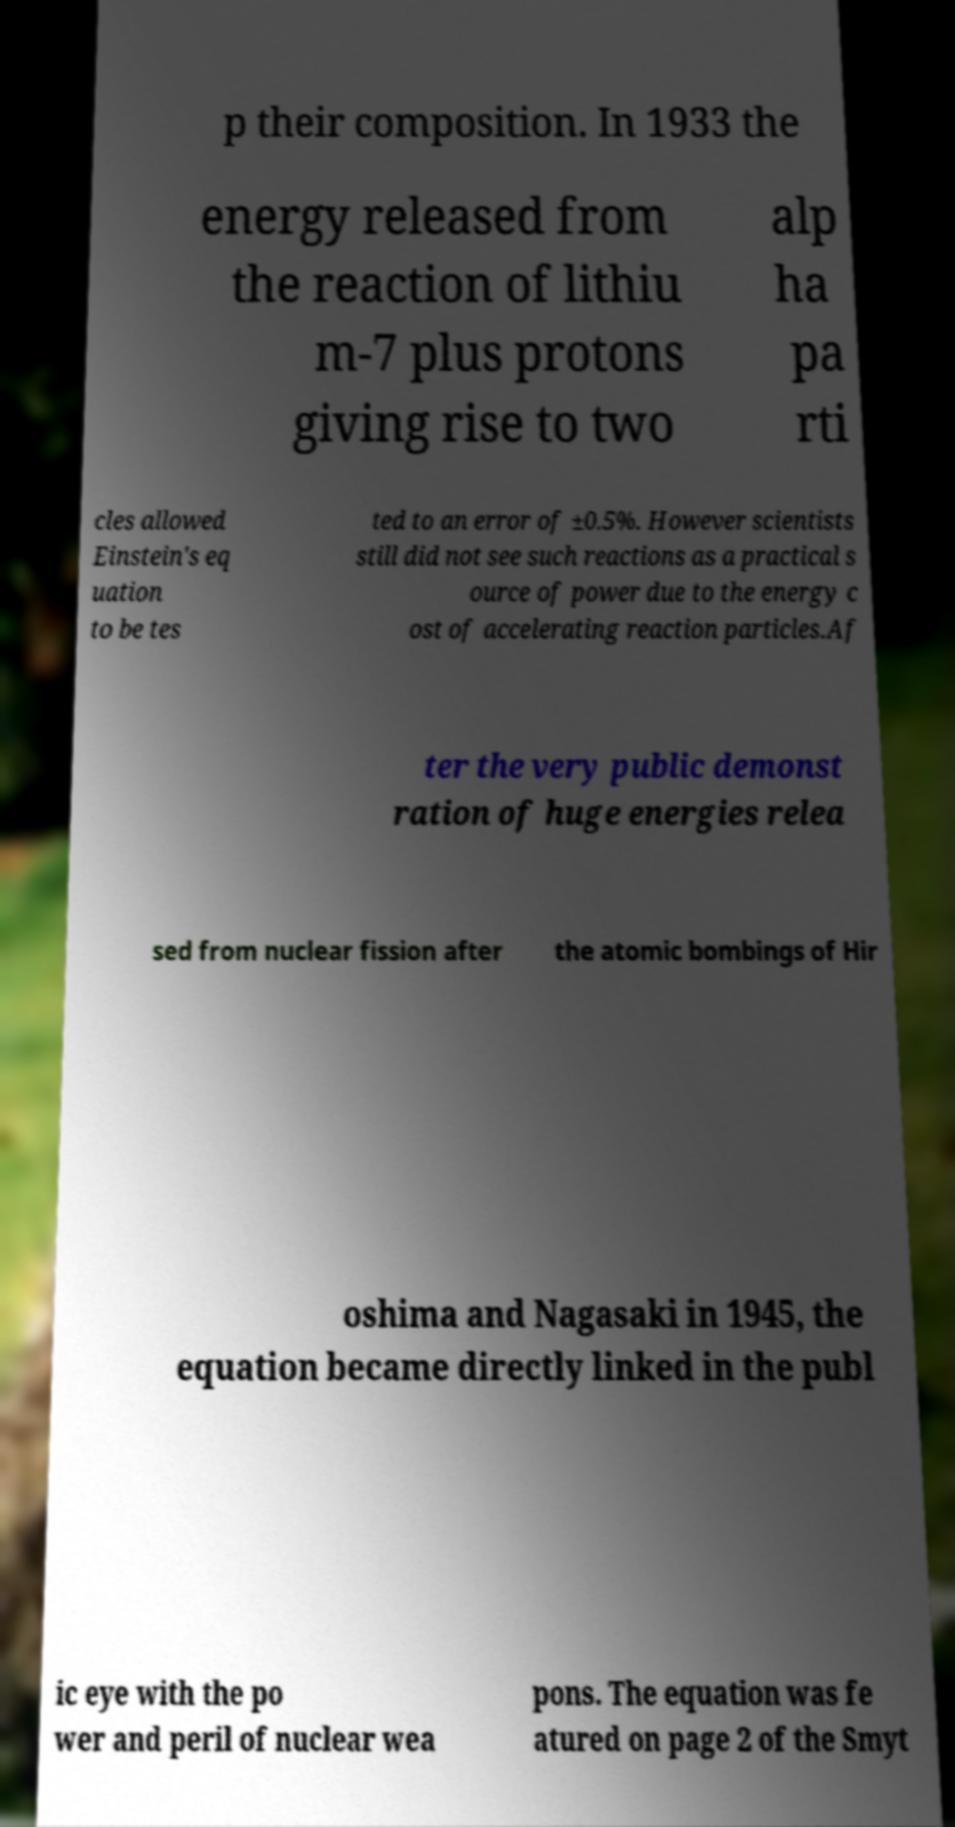For documentation purposes, I need the text within this image transcribed. Could you provide that? p their composition. In 1933 the energy released from the reaction of lithiu m-7 plus protons giving rise to two alp ha pa rti cles allowed Einstein's eq uation to be tes ted to an error of ±0.5%. However scientists still did not see such reactions as a practical s ource of power due to the energy c ost of accelerating reaction particles.Af ter the very public demonst ration of huge energies relea sed from nuclear fission after the atomic bombings of Hir oshima and Nagasaki in 1945, the equation became directly linked in the publ ic eye with the po wer and peril of nuclear wea pons. The equation was fe atured on page 2 of the Smyt 